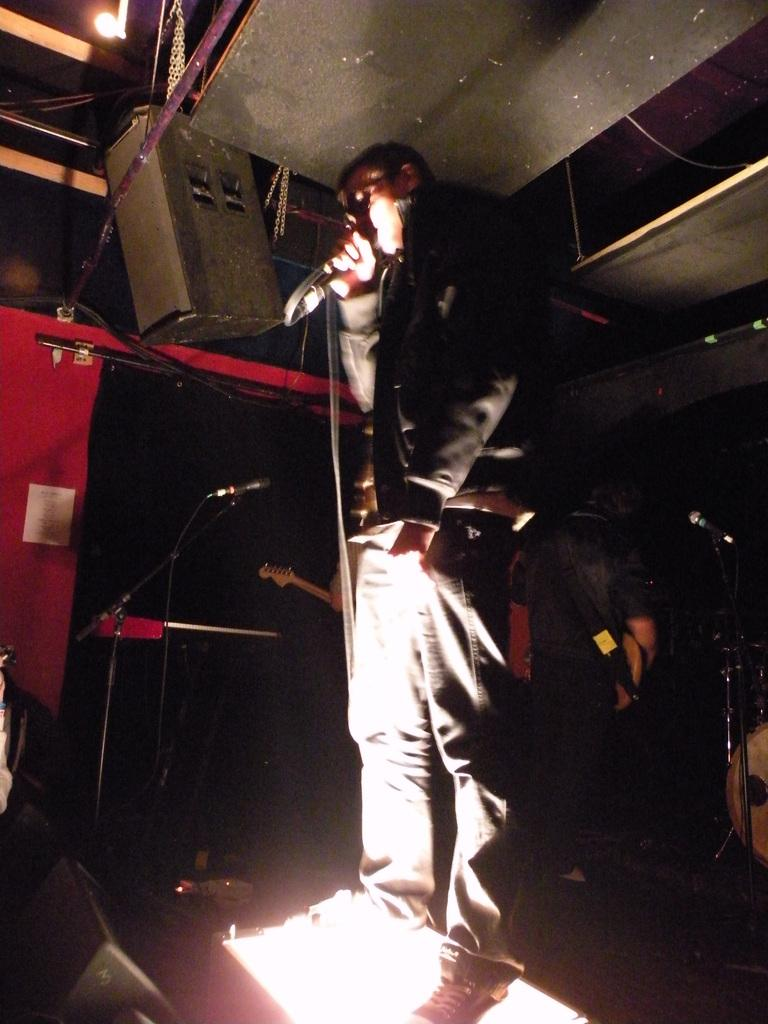What is the person in the image wearing? There is a person with a dress in the image. What is the person holding in the image? The person is holding a mic. How many mics can be seen in the image? There are mics visible in the image. What other items related to music can be seen in the image? There are musical instruments and speakers in the image. What is the source of light in the image? There is a light at the top of the image. What statement does the porter make about the school in the image? There is no porter or school present in the image, so no such statement can be made. 